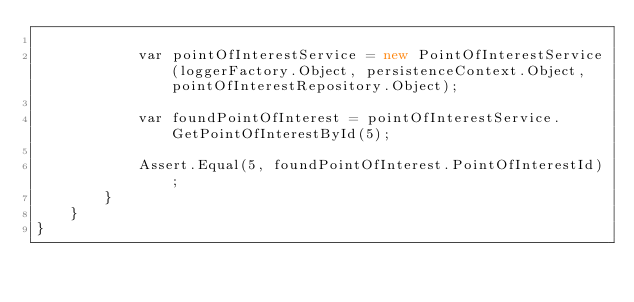<code> <loc_0><loc_0><loc_500><loc_500><_C#_>
            var pointOfInterestService = new PointOfInterestService(loggerFactory.Object, persistenceContext.Object, pointOfInterestRepository.Object);

            var foundPointOfInterest = pointOfInterestService.GetPointOfInterestById(5);

            Assert.Equal(5, foundPointOfInterest.PointOfInterestId);
        }
    }
}
</code> 